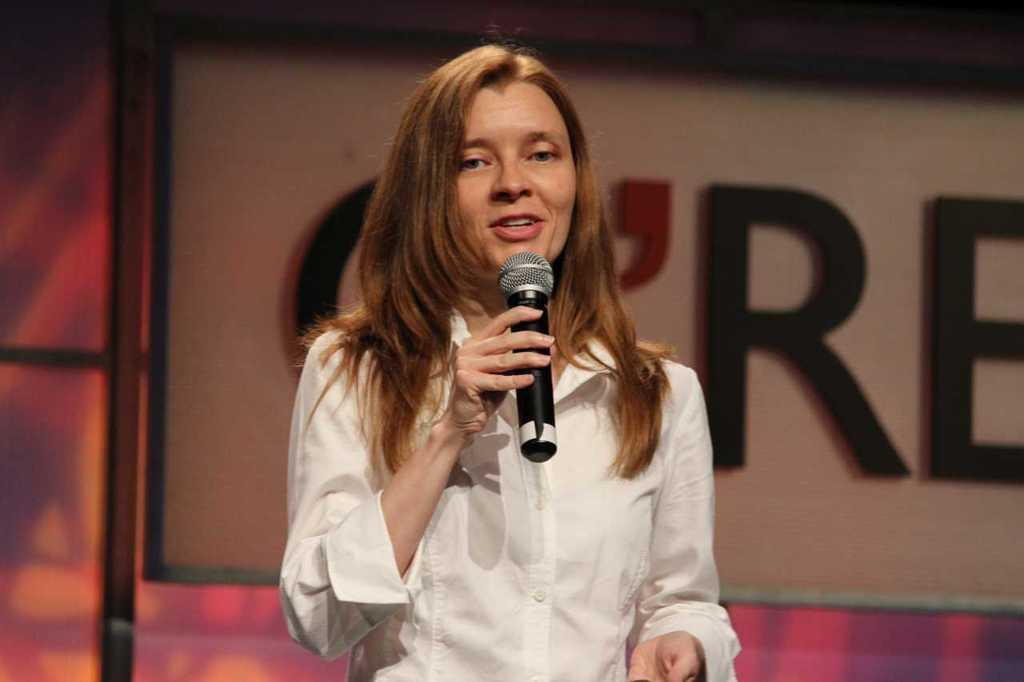Who is the main subject in the image? There is a lady in the center of the image. What is the lady holding in her hand? The lady is holding a mic in her hand. What can be seen in the background of the image? There is a poster in the background of the image. How many bikes are parked next to the lady in the image? There are no bikes present in the image. What color is the ladybug on the lady's shoulder in the image? There is no ladybug present in the image. 